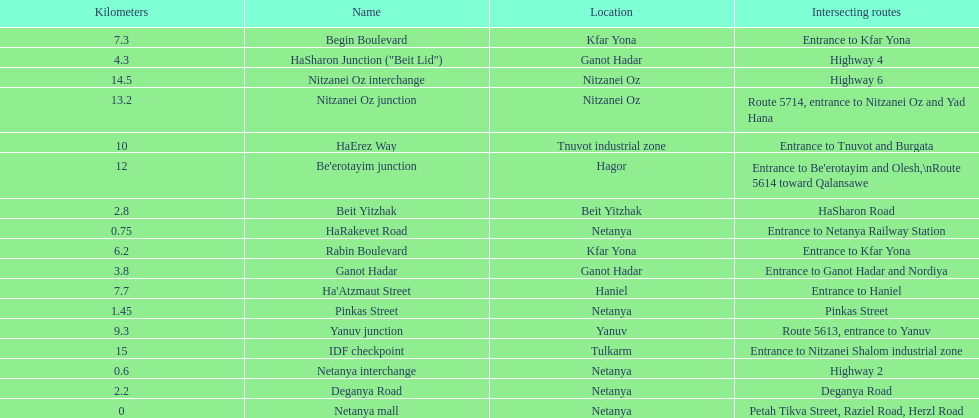How many locations in netanya are there? 5. 